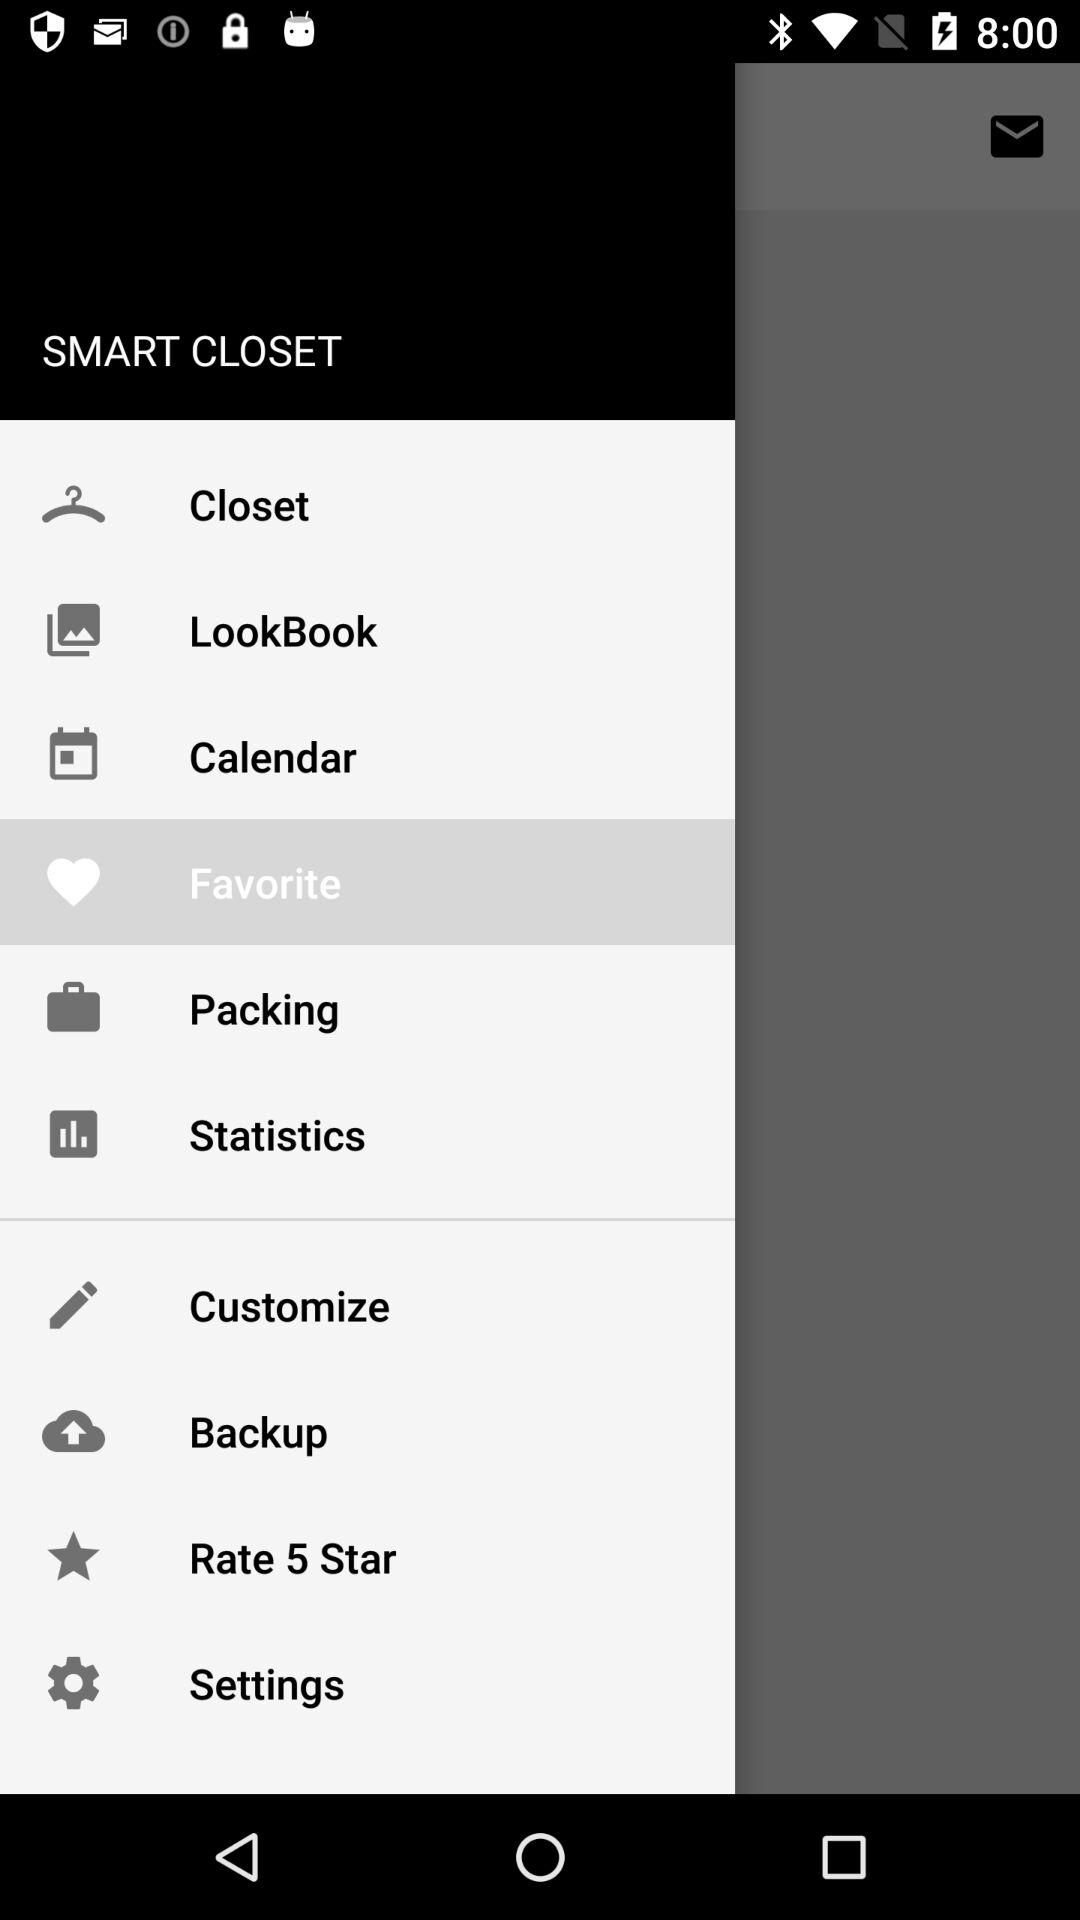What is the name of the application? The name of the application is "SMART CLOSET". 